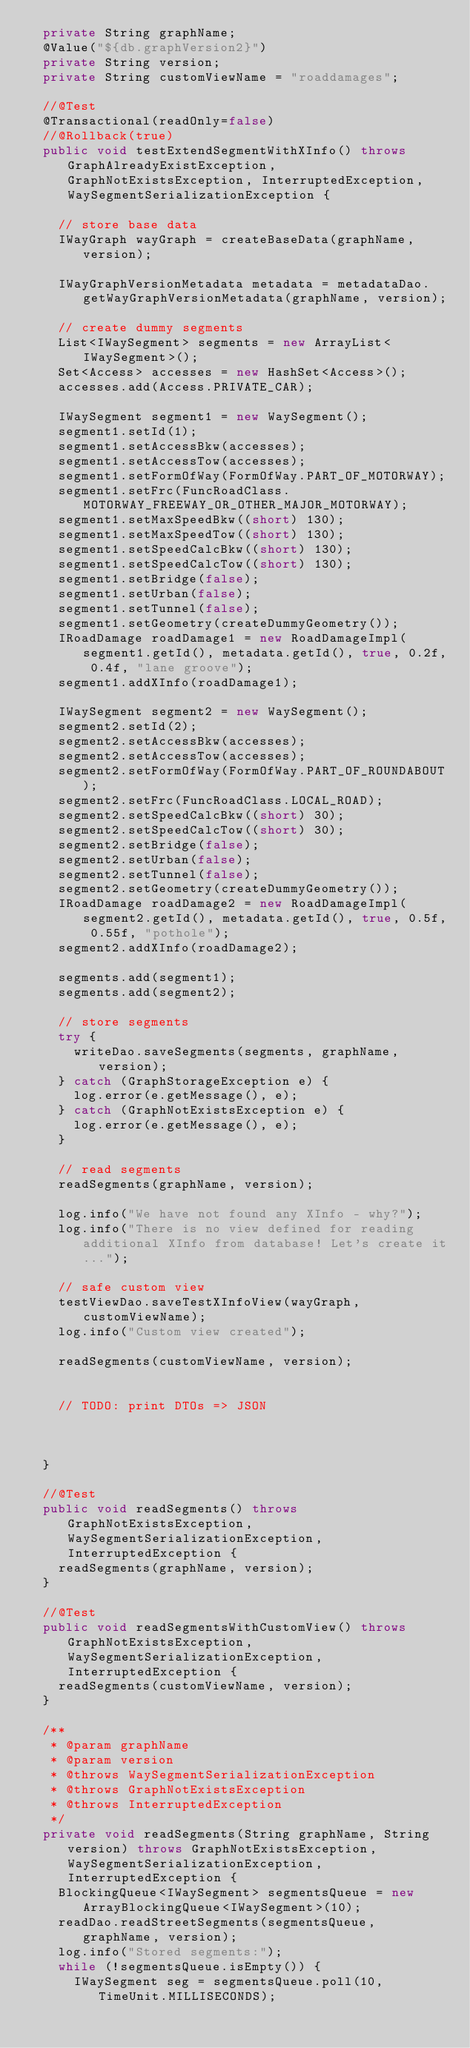Convert code to text. <code><loc_0><loc_0><loc_500><loc_500><_Java_>	private String graphName;
	@Value("${db.graphVersion2}")
	private String version;
	private String customViewName = "roaddamages";

	//@Test
	@Transactional(readOnly=false)
	//@Rollback(true)
	public void testExtendSegmentWithXInfo() throws GraphAlreadyExistException, GraphNotExistsException, InterruptedException, WaySegmentSerializationException {

		// store base data
		IWayGraph wayGraph = createBaseData(graphName, version);
		
		IWayGraphVersionMetadata metadata = metadataDao.getWayGraphVersionMetadata(graphName, version);
		
		// create dummy segments
		List<IWaySegment> segments = new ArrayList<IWaySegment>();
		Set<Access> accesses = new HashSet<Access>();
		accesses.add(Access.PRIVATE_CAR);
		
		IWaySegment segment1 = new WaySegment();
		segment1.setId(1);
		segment1.setAccessBkw(accesses);
		segment1.setAccessTow(accesses);
		segment1.setFormOfWay(FormOfWay.PART_OF_MOTORWAY);
		segment1.setFrc(FuncRoadClass.MOTORWAY_FREEWAY_OR_OTHER_MAJOR_MOTORWAY);
		segment1.setMaxSpeedBkw((short) 130);
		segment1.setMaxSpeedTow((short) 130);
		segment1.setSpeedCalcBkw((short) 130);
		segment1.setSpeedCalcTow((short) 130);
		segment1.setBridge(false);
		segment1.setUrban(false);
		segment1.setTunnel(false);
		segment1.setGeometry(createDummyGeometry());
		IRoadDamage roadDamage1 = new RoadDamageImpl(segment1.getId(), metadata.getId(), true, 0.2f, 0.4f, "lane groove");
		segment1.addXInfo(roadDamage1);
		
		IWaySegment segment2 = new WaySegment();
		segment2.setId(2);
		segment2.setAccessBkw(accesses);
		segment2.setAccessTow(accesses);
		segment2.setFormOfWay(FormOfWay.PART_OF_ROUNDABOUT);
		segment2.setFrc(FuncRoadClass.LOCAL_ROAD);
		segment2.setSpeedCalcBkw((short) 30);
		segment2.setSpeedCalcTow((short) 30);
		segment2.setBridge(false);
		segment2.setUrban(false);
		segment2.setTunnel(false);
		segment2.setGeometry(createDummyGeometry());
		IRoadDamage roadDamage2 = new RoadDamageImpl(segment2.getId(), metadata.getId(), true, 0.5f, 0.55f, "pothole");
		segment2.addXInfo(roadDamage2);
		
		segments.add(segment1);
		segments.add(segment2);
		
		// store segments
		try {
			writeDao.saveSegments(segments, graphName, version);
		} catch (GraphStorageException e) {
			log.error(e.getMessage(), e);
		} catch (GraphNotExistsException e) {
			log.error(e.getMessage(), e);
		}
		
		// read segments
		readSegments(graphName, version);
		
		log.info("We have not found any XInfo - why?");
		log.info("There is no view defined for reading additional XInfo from database! Let's create it...");
		
		// safe custom view
		testViewDao.saveTestXInfoView(wayGraph, customViewName);
		log.info("Custom view created");

		readSegments(customViewName, version);

		
		// TODO: print DTOs => JSON
		
		
	
	}
	
	//@Test
	public void readSegments() throws GraphNotExistsException, WaySegmentSerializationException, InterruptedException {
		readSegments(graphName, version);
	}
	
	//@Test
	public void readSegmentsWithCustomView() throws GraphNotExistsException, WaySegmentSerializationException, InterruptedException {
		readSegments(customViewName, version);
	}
	
	/**
	 * @param graphName
	 * @param version
	 * @throws WaySegmentSerializationException 
	 * @throws GraphNotExistsException 
	 * @throws InterruptedException 
	 */
	private void readSegments(String graphName, String version) throws GraphNotExistsException, WaySegmentSerializationException, InterruptedException {
		BlockingQueue<IWaySegment> segmentsQueue = new ArrayBlockingQueue<IWaySegment>(10);
		readDao.readStreetSegments(segmentsQueue, graphName, version);
		log.info("Stored segments:");
		while (!segmentsQueue.isEmpty()) {
			IWaySegment seg = segmentsQueue.poll(10, TimeUnit.MILLISECONDS);</code> 